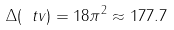Convert formula to latex. <formula><loc_0><loc_0><loc_500><loc_500>\Delta ( \ t v ) = 1 8 \pi ^ { 2 } \approx 1 7 7 . 7</formula> 